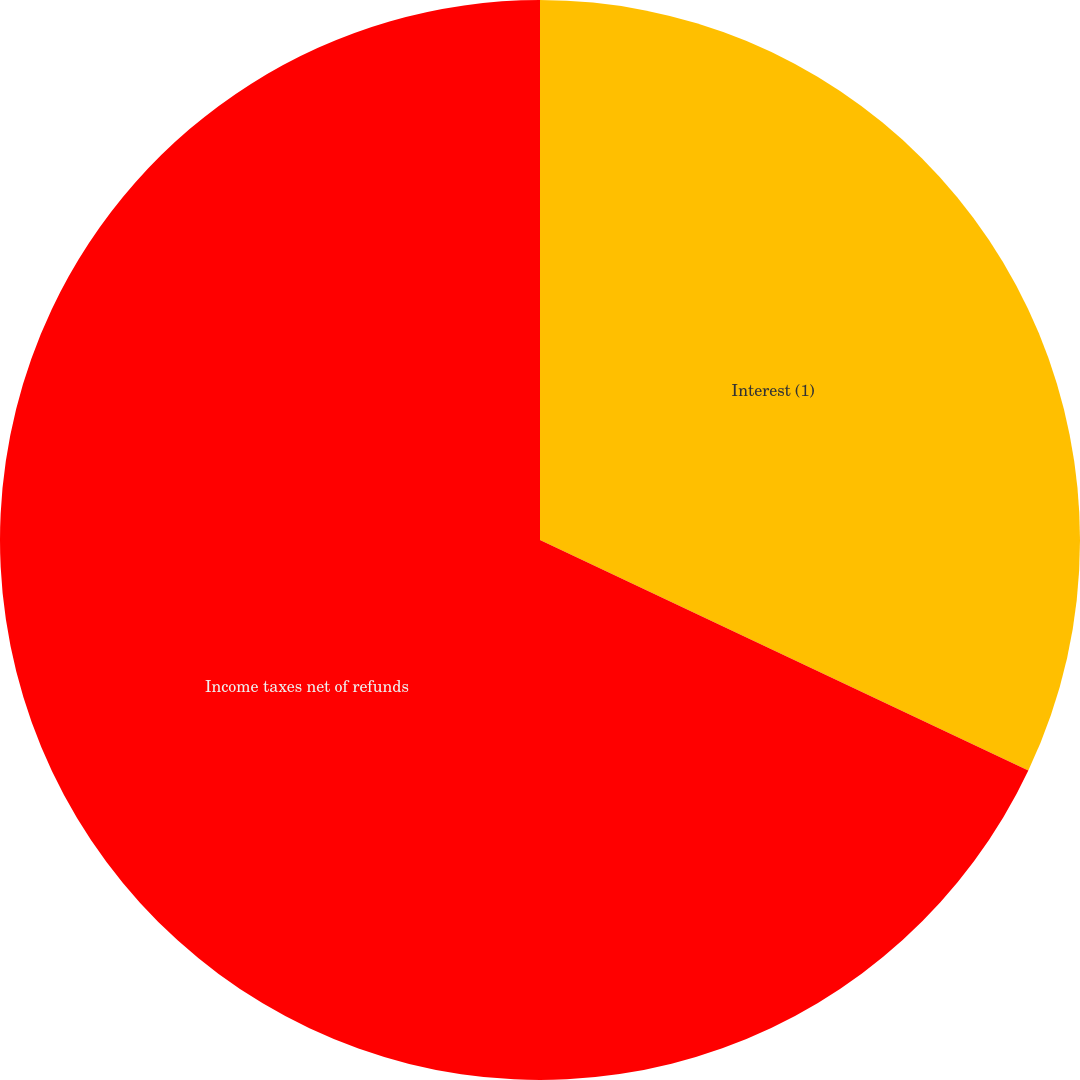Convert chart. <chart><loc_0><loc_0><loc_500><loc_500><pie_chart><fcel>Interest (1)<fcel>Income taxes net of refunds<nl><fcel>32.02%<fcel>67.98%<nl></chart> 